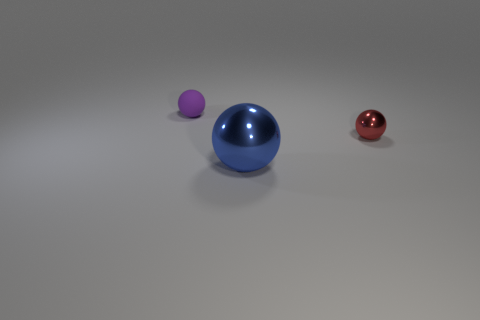Add 1 big cyan things. How many objects exist? 4 Add 2 small green metallic spheres. How many small green metallic spheres exist? 2 Subtract 0 yellow blocks. How many objects are left? 3 Subtract all cyan cylinders. Subtract all large blue spheres. How many objects are left? 2 Add 2 purple objects. How many purple objects are left? 3 